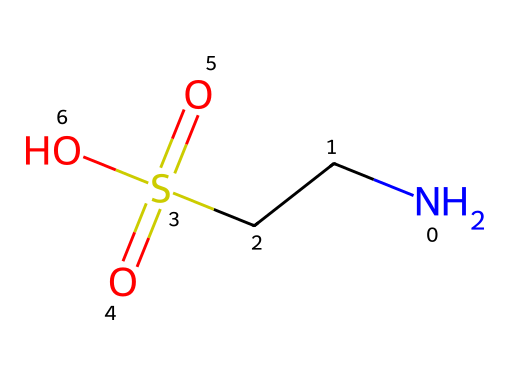What is the name of this chemical? The structure reveals that it contains a sulfonic acid group (-SO3H) and an amine group (-NH2). These functional groups are characteristic of taurine.
Answer: taurine How many sulfur atoms are present in this molecule? By inspecting the chemical structure, there's one sulfonic acid group which contains a single sulfur atom.
Answer: one What is the total number of oxygen atoms in taurine? From the structure, there are three oxygen atoms visible: two from the sulfonic group and one from the hydroxyl group (-OH).
Answer: three What type of functional group is present in taurine that relates to its acidity? The presence of the -SO3H group indicates that taurine has a sulfonic acid functional group, which contributes to its acidic properties.
Answer: sulfonic acid Does taurine contain any carbon atoms in its structure? Analyzing the SMILES representation, there are two carbon atoms (C) present in the main chain of the amino acid.
Answer: two What potential role does taurine play in sports beverages? Taurine is often included in sports beverages due to its role in enhancing hydration and performance, particularly through its involvement in muscle function.
Answer: hydration and performance Is taurine classified as a natural or synthetic additive? Taurine is primarily considered a natural amino acid, as it can be found in various foods and is synthesized in the body.
Answer: natural 